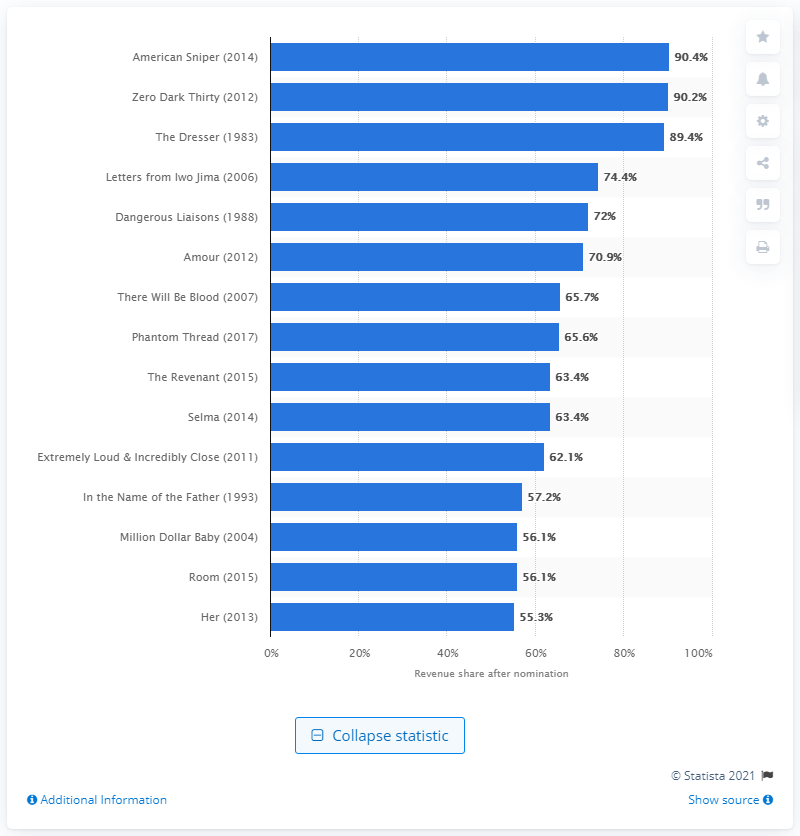Specify some key components in this picture. After its nomination, American Sniper generated 90.4% of its domestic box office revenue. 